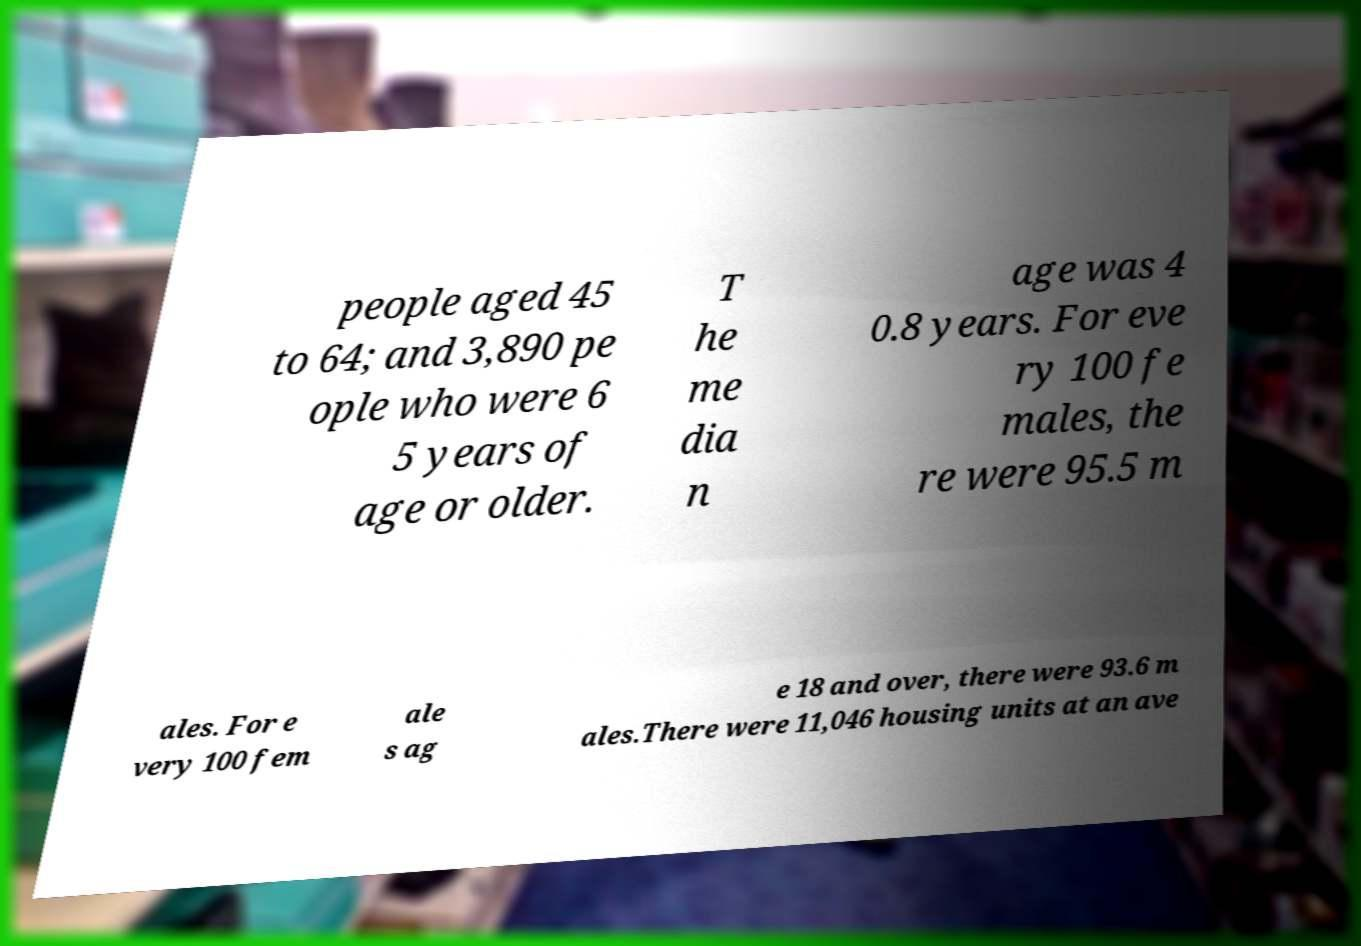Can you read and provide the text displayed in the image?This photo seems to have some interesting text. Can you extract and type it out for me? people aged 45 to 64; and 3,890 pe ople who were 6 5 years of age or older. T he me dia n age was 4 0.8 years. For eve ry 100 fe males, the re were 95.5 m ales. For e very 100 fem ale s ag e 18 and over, there were 93.6 m ales.There were 11,046 housing units at an ave 